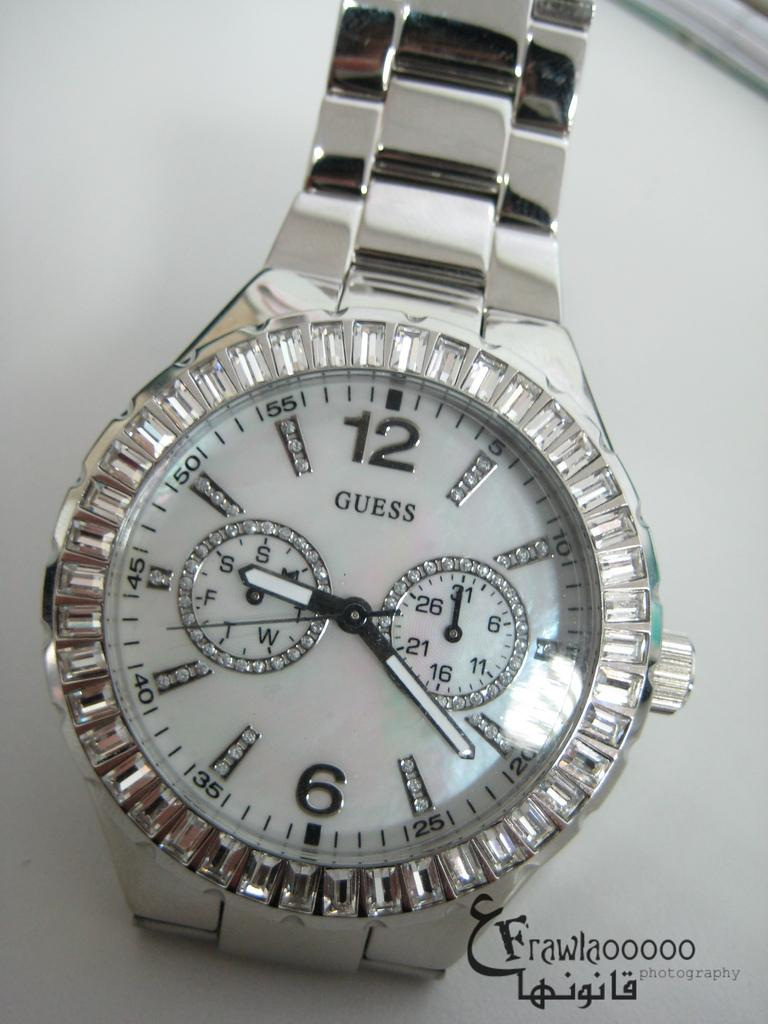<image>
Share a concise interpretation of the image provided. A silver Guess watch is adorned with crystals. 